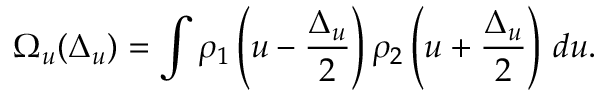Convert formula to latex. <formula><loc_0><loc_0><loc_500><loc_500>\Omega _ { u } ( \Delta _ { u } ) = \int \rho _ { 1 } \left ( u - \frac { \Delta _ { u } } { 2 } \right ) \rho _ { 2 } \left ( u + \frac { \Delta _ { u } } { 2 } \right ) \, d u .</formula> 